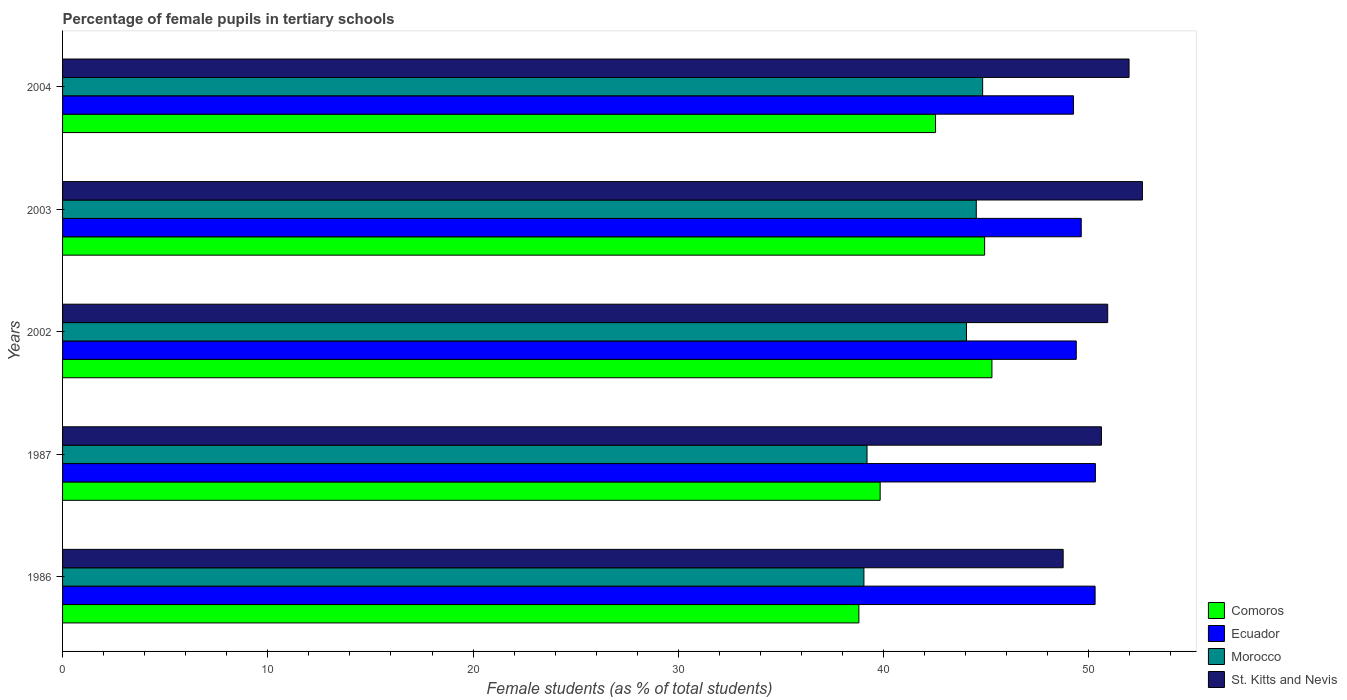How many different coloured bars are there?
Provide a succinct answer. 4. How many groups of bars are there?
Offer a very short reply. 5. Are the number of bars per tick equal to the number of legend labels?
Provide a short and direct response. Yes. How many bars are there on the 1st tick from the top?
Make the answer very short. 4. What is the label of the 2nd group of bars from the top?
Your answer should be compact. 2003. What is the percentage of female pupils in tertiary schools in St. Kitts and Nevis in 1987?
Keep it short and to the point. 50.61. Across all years, what is the maximum percentage of female pupils in tertiary schools in Morocco?
Make the answer very short. 44.83. Across all years, what is the minimum percentage of female pupils in tertiary schools in St. Kitts and Nevis?
Provide a short and direct response. 48.75. What is the total percentage of female pupils in tertiary schools in St. Kitts and Nevis in the graph?
Make the answer very short. 254.85. What is the difference between the percentage of female pupils in tertiary schools in Morocco in 2002 and that in 2004?
Make the answer very short. -0.79. What is the difference between the percentage of female pupils in tertiary schools in Morocco in 2004 and the percentage of female pupils in tertiary schools in Comoros in 2003?
Keep it short and to the point. -0.1. What is the average percentage of female pupils in tertiary schools in Comoros per year?
Offer a terse response. 42.27. In the year 1986, what is the difference between the percentage of female pupils in tertiary schools in Ecuador and percentage of female pupils in tertiary schools in Comoros?
Provide a short and direct response. 11.51. In how many years, is the percentage of female pupils in tertiary schools in St. Kitts and Nevis greater than 8 %?
Your answer should be compact. 5. What is the ratio of the percentage of female pupils in tertiary schools in Morocco in 1986 to that in 1987?
Offer a very short reply. 1. What is the difference between the highest and the second highest percentage of female pupils in tertiary schools in Ecuador?
Give a very brief answer. 0.02. What is the difference between the highest and the lowest percentage of female pupils in tertiary schools in Ecuador?
Provide a succinct answer. 1.07. In how many years, is the percentage of female pupils in tertiary schools in Morocco greater than the average percentage of female pupils in tertiary schools in Morocco taken over all years?
Give a very brief answer. 3. Is it the case that in every year, the sum of the percentage of female pupils in tertiary schools in Comoros and percentage of female pupils in tertiary schools in St. Kitts and Nevis is greater than the sum of percentage of female pupils in tertiary schools in Ecuador and percentage of female pupils in tertiary schools in Morocco?
Your response must be concise. Yes. What does the 2nd bar from the top in 2003 represents?
Keep it short and to the point. Morocco. What does the 4th bar from the bottom in 1987 represents?
Provide a succinct answer. St. Kitts and Nevis. Are all the bars in the graph horizontal?
Make the answer very short. Yes. What is the difference between two consecutive major ticks on the X-axis?
Offer a terse response. 10. Are the values on the major ticks of X-axis written in scientific E-notation?
Your answer should be very brief. No. Does the graph contain grids?
Give a very brief answer. No. Where does the legend appear in the graph?
Ensure brevity in your answer.  Bottom right. How many legend labels are there?
Your answer should be compact. 4. How are the legend labels stacked?
Ensure brevity in your answer.  Vertical. What is the title of the graph?
Provide a succinct answer. Percentage of female pupils in tertiary schools. Does "Azerbaijan" appear as one of the legend labels in the graph?
Provide a short and direct response. No. What is the label or title of the X-axis?
Your answer should be compact. Female students (as % of total students). What is the label or title of the Y-axis?
Ensure brevity in your answer.  Years. What is the Female students (as % of total students) of Comoros in 1986?
Your answer should be compact. 38.8. What is the Female students (as % of total students) of Ecuador in 1986?
Keep it short and to the point. 50.31. What is the Female students (as % of total students) in Morocco in 1986?
Give a very brief answer. 39.04. What is the Female students (as % of total students) of St. Kitts and Nevis in 1986?
Keep it short and to the point. 48.75. What is the Female students (as % of total students) of Comoros in 1987?
Make the answer very short. 39.83. What is the Female students (as % of total students) in Ecuador in 1987?
Your response must be concise. 50.32. What is the Female students (as % of total students) of Morocco in 1987?
Keep it short and to the point. 39.19. What is the Female students (as % of total students) of St. Kitts and Nevis in 1987?
Make the answer very short. 50.61. What is the Female students (as % of total students) in Comoros in 2002?
Ensure brevity in your answer.  45.28. What is the Female students (as % of total students) in Ecuador in 2002?
Make the answer very short. 49.39. What is the Female students (as % of total students) of Morocco in 2002?
Provide a short and direct response. 44.04. What is the Female students (as % of total students) in St. Kitts and Nevis in 2002?
Provide a short and direct response. 50.92. What is the Female students (as % of total students) of Comoros in 2003?
Your answer should be compact. 44.92. What is the Female students (as % of total students) in Ecuador in 2003?
Give a very brief answer. 49.63. What is the Female students (as % of total students) in Morocco in 2003?
Ensure brevity in your answer.  44.52. What is the Female students (as % of total students) of St. Kitts and Nevis in 2003?
Provide a short and direct response. 52.61. What is the Female students (as % of total students) of Comoros in 2004?
Keep it short and to the point. 42.53. What is the Female students (as % of total students) in Ecuador in 2004?
Make the answer very short. 49.25. What is the Female students (as % of total students) of Morocco in 2004?
Your response must be concise. 44.83. What is the Female students (as % of total students) in St. Kitts and Nevis in 2004?
Your answer should be very brief. 51.96. Across all years, what is the maximum Female students (as % of total students) of Comoros?
Provide a succinct answer. 45.28. Across all years, what is the maximum Female students (as % of total students) in Ecuador?
Offer a terse response. 50.32. Across all years, what is the maximum Female students (as % of total students) in Morocco?
Your answer should be very brief. 44.83. Across all years, what is the maximum Female students (as % of total students) of St. Kitts and Nevis?
Make the answer very short. 52.61. Across all years, what is the minimum Female students (as % of total students) of Comoros?
Provide a succinct answer. 38.8. Across all years, what is the minimum Female students (as % of total students) of Ecuador?
Keep it short and to the point. 49.25. Across all years, what is the minimum Female students (as % of total students) in Morocco?
Keep it short and to the point. 39.04. Across all years, what is the minimum Female students (as % of total students) in St. Kitts and Nevis?
Ensure brevity in your answer.  48.75. What is the total Female students (as % of total students) in Comoros in the graph?
Provide a succinct answer. 211.36. What is the total Female students (as % of total students) in Ecuador in the graph?
Offer a terse response. 248.9. What is the total Female students (as % of total students) of Morocco in the graph?
Provide a succinct answer. 211.62. What is the total Female students (as % of total students) in St. Kitts and Nevis in the graph?
Ensure brevity in your answer.  254.85. What is the difference between the Female students (as % of total students) of Comoros in 1986 and that in 1987?
Provide a short and direct response. -1.04. What is the difference between the Female students (as % of total students) in Ecuador in 1986 and that in 1987?
Offer a terse response. -0.02. What is the difference between the Female students (as % of total students) in Morocco in 1986 and that in 1987?
Offer a very short reply. -0.15. What is the difference between the Female students (as % of total students) of St. Kitts and Nevis in 1986 and that in 1987?
Your response must be concise. -1.86. What is the difference between the Female students (as % of total students) of Comoros in 1986 and that in 2002?
Your answer should be very brief. -6.48. What is the difference between the Female students (as % of total students) in Ecuador in 1986 and that in 2002?
Provide a succinct answer. 0.92. What is the difference between the Female students (as % of total students) in Morocco in 1986 and that in 2002?
Provide a short and direct response. -5. What is the difference between the Female students (as % of total students) in St. Kitts and Nevis in 1986 and that in 2002?
Your response must be concise. -2.17. What is the difference between the Female students (as % of total students) in Comoros in 1986 and that in 2003?
Give a very brief answer. -6.13. What is the difference between the Female students (as % of total students) of Ecuador in 1986 and that in 2003?
Give a very brief answer. 0.68. What is the difference between the Female students (as % of total students) in Morocco in 1986 and that in 2003?
Your answer should be very brief. -5.47. What is the difference between the Female students (as % of total students) of St. Kitts and Nevis in 1986 and that in 2003?
Offer a very short reply. -3.86. What is the difference between the Female students (as % of total students) in Comoros in 1986 and that in 2004?
Your answer should be very brief. -3.73. What is the difference between the Female students (as % of total students) of Ecuador in 1986 and that in 2004?
Your response must be concise. 1.05. What is the difference between the Female students (as % of total students) of Morocco in 1986 and that in 2004?
Your response must be concise. -5.78. What is the difference between the Female students (as % of total students) of St. Kitts and Nevis in 1986 and that in 2004?
Provide a short and direct response. -3.21. What is the difference between the Female students (as % of total students) of Comoros in 1987 and that in 2002?
Make the answer very short. -5.45. What is the difference between the Female students (as % of total students) of Ecuador in 1987 and that in 2002?
Provide a succinct answer. 0.93. What is the difference between the Female students (as % of total students) in Morocco in 1987 and that in 2002?
Ensure brevity in your answer.  -4.85. What is the difference between the Female students (as % of total students) of St. Kitts and Nevis in 1987 and that in 2002?
Offer a terse response. -0.31. What is the difference between the Female students (as % of total students) of Comoros in 1987 and that in 2003?
Give a very brief answer. -5.09. What is the difference between the Female students (as % of total students) of Ecuador in 1987 and that in 2003?
Offer a very short reply. 0.69. What is the difference between the Female students (as % of total students) of Morocco in 1987 and that in 2003?
Keep it short and to the point. -5.32. What is the difference between the Female students (as % of total students) of St. Kitts and Nevis in 1987 and that in 2003?
Offer a terse response. -2. What is the difference between the Female students (as % of total students) in Comoros in 1987 and that in 2004?
Your answer should be very brief. -2.7. What is the difference between the Female students (as % of total students) of Ecuador in 1987 and that in 2004?
Your response must be concise. 1.07. What is the difference between the Female students (as % of total students) in Morocco in 1987 and that in 2004?
Your answer should be very brief. -5.63. What is the difference between the Female students (as % of total students) of St. Kitts and Nevis in 1987 and that in 2004?
Your response must be concise. -1.35. What is the difference between the Female students (as % of total students) of Comoros in 2002 and that in 2003?
Provide a short and direct response. 0.36. What is the difference between the Female students (as % of total students) in Ecuador in 2002 and that in 2003?
Offer a terse response. -0.24. What is the difference between the Female students (as % of total students) of Morocco in 2002 and that in 2003?
Offer a terse response. -0.48. What is the difference between the Female students (as % of total students) in St. Kitts and Nevis in 2002 and that in 2003?
Your answer should be very brief. -1.69. What is the difference between the Female students (as % of total students) of Comoros in 2002 and that in 2004?
Give a very brief answer. 2.75. What is the difference between the Female students (as % of total students) in Ecuador in 2002 and that in 2004?
Provide a succinct answer. 0.13. What is the difference between the Female students (as % of total students) in Morocco in 2002 and that in 2004?
Give a very brief answer. -0.79. What is the difference between the Female students (as % of total students) of St. Kitts and Nevis in 2002 and that in 2004?
Your answer should be compact. -1.04. What is the difference between the Female students (as % of total students) of Comoros in 2003 and that in 2004?
Provide a short and direct response. 2.39. What is the difference between the Female students (as % of total students) in Ecuador in 2003 and that in 2004?
Ensure brevity in your answer.  0.38. What is the difference between the Female students (as % of total students) of Morocco in 2003 and that in 2004?
Give a very brief answer. -0.31. What is the difference between the Female students (as % of total students) of St. Kitts and Nevis in 2003 and that in 2004?
Your answer should be very brief. 0.65. What is the difference between the Female students (as % of total students) in Comoros in 1986 and the Female students (as % of total students) in Ecuador in 1987?
Your answer should be compact. -11.52. What is the difference between the Female students (as % of total students) of Comoros in 1986 and the Female students (as % of total students) of Morocco in 1987?
Provide a short and direct response. -0.4. What is the difference between the Female students (as % of total students) of Comoros in 1986 and the Female students (as % of total students) of St. Kitts and Nevis in 1987?
Ensure brevity in your answer.  -11.82. What is the difference between the Female students (as % of total students) of Ecuador in 1986 and the Female students (as % of total students) of Morocco in 1987?
Your response must be concise. 11.11. What is the difference between the Female students (as % of total students) in Ecuador in 1986 and the Female students (as % of total students) in St. Kitts and Nevis in 1987?
Ensure brevity in your answer.  -0.31. What is the difference between the Female students (as % of total students) of Morocco in 1986 and the Female students (as % of total students) of St. Kitts and Nevis in 1987?
Offer a very short reply. -11.57. What is the difference between the Female students (as % of total students) in Comoros in 1986 and the Female students (as % of total students) in Ecuador in 2002?
Keep it short and to the point. -10.59. What is the difference between the Female students (as % of total students) of Comoros in 1986 and the Female students (as % of total students) of Morocco in 2002?
Provide a short and direct response. -5.24. What is the difference between the Female students (as % of total students) of Comoros in 1986 and the Female students (as % of total students) of St. Kitts and Nevis in 2002?
Keep it short and to the point. -12.12. What is the difference between the Female students (as % of total students) in Ecuador in 1986 and the Female students (as % of total students) in Morocco in 2002?
Give a very brief answer. 6.26. What is the difference between the Female students (as % of total students) in Ecuador in 1986 and the Female students (as % of total students) in St. Kitts and Nevis in 2002?
Ensure brevity in your answer.  -0.61. What is the difference between the Female students (as % of total students) in Morocco in 1986 and the Female students (as % of total students) in St. Kitts and Nevis in 2002?
Offer a very short reply. -11.88. What is the difference between the Female students (as % of total students) in Comoros in 1986 and the Female students (as % of total students) in Ecuador in 2003?
Offer a very short reply. -10.83. What is the difference between the Female students (as % of total students) in Comoros in 1986 and the Female students (as % of total students) in Morocco in 2003?
Offer a terse response. -5.72. What is the difference between the Female students (as % of total students) in Comoros in 1986 and the Female students (as % of total students) in St. Kitts and Nevis in 2003?
Keep it short and to the point. -13.81. What is the difference between the Female students (as % of total students) in Ecuador in 1986 and the Female students (as % of total students) in Morocco in 2003?
Offer a terse response. 5.79. What is the difference between the Female students (as % of total students) in Ecuador in 1986 and the Female students (as % of total students) in St. Kitts and Nevis in 2003?
Keep it short and to the point. -2.31. What is the difference between the Female students (as % of total students) in Morocco in 1986 and the Female students (as % of total students) in St. Kitts and Nevis in 2003?
Your answer should be compact. -13.57. What is the difference between the Female students (as % of total students) of Comoros in 1986 and the Female students (as % of total students) of Ecuador in 2004?
Your answer should be compact. -10.46. What is the difference between the Female students (as % of total students) in Comoros in 1986 and the Female students (as % of total students) in Morocco in 2004?
Make the answer very short. -6.03. What is the difference between the Female students (as % of total students) of Comoros in 1986 and the Female students (as % of total students) of St. Kitts and Nevis in 2004?
Keep it short and to the point. -13.16. What is the difference between the Female students (as % of total students) in Ecuador in 1986 and the Female students (as % of total students) in Morocco in 2004?
Make the answer very short. 5.48. What is the difference between the Female students (as % of total students) of Ecuador in 1986 and the Female students (as % of total students) of St. Kitts and Nevis in 2004?
Provide a short and direct response. -1.65. What is the difference between the Female students (as % of total students) in Morocco in 1986 and the Female students (as % of total students) in St. Kitts and Nevis in 2004?
Give a very brief answer. -12.92. What is the difference between the Female students (as % of total students) of Comoros in 1987 and the Female students (as % of total students) of Ecuador in 2002?
Offer a terse response. -9.55. What is the difference between the Female students (as % of total students) in Comoros in 1987 and the Female students (as % of total students) in Morocco in 2002?
Keep it short and to the point. -4.21. What is the difference between the Female students (as % of total students) in Comoros in 1987 and the Female students (as % of total students) in St. Kitts and Nevis in 2002?
Make the answer very short. -11.09. What is the difference between the Female students (as % of total students) in Ecuador in 1987 and the Female students (as % of total students) in Morocco in 2002?
Your response must be concise. 6.28. What is the difference between the Female students (as % of total students) of Ecuador in 1987 and the Female students (as % of total students) of St. Kitts and Nevis in 2002?
Offer a very short reply. -0.6. What is the difference between the Female students (as % of total students) of Morocco in 1987 and the Female students (as % of total students) of St. Kitts and Nevis in 2002?
Offer a terse response. -11.73. What is the difference between the Female students (as % of total students) of Comoros in 1987 and the Female students (as % of total students) of Ecuador in 2003?
Offer a very short reply. -9.8. What is the difference between the Female students (as % of total students) of Comoros in 1987 and the Female students (as % of total students) of Morocco in 2003?
Make the answer very short. -4.68. What is the difference between the Female students (as % of total students) of Comoros in 1987 and the Female students (as % of total students) of St. Kitts and Nevis in 2003?
Make the answer very short. -12.78. What is the difference between the Female students (as % of total students) in Ecuador in 1987 and the Female students (as % of total students) in Morocco in 2003?
Keep it short and to the point. 5.8. What is the difference between the Female students (as % of total students) of Ecuador in 1987 and the Female students (as % of total students) of St. Kitts and Nevis in 2003?
Provide a short and direct response. -2.29. What is the difference between the Female students (as % of total students) in Morocco in 1987 and the Female students (as % of total students) in St. Kitts and Nevis in 2003?
Provide a succinct answer. -13.42. What is the difference between the Female students (as % of total students) of Comoros in 1987 and the Female students (as % of total students) of Ecuador in 2004?
Offer a terse response. -9.42. What is the difference between the Female students (as % of total students) in Comoros in 1987 and the Female students (as % of total students) in Morocco in 2004?
Give a very brief answer. -4.99. What is the difference between the Female students (as % of total students) in Comoros in 1987 and the Female students (as % of total students) in St. Kitts and Nevis in 2004?
Give a very brief answer. -12.13. What is the difference between the Female students (as % of total students) of Ecuador in 1987 and the Female students (as % of total students) of Morocco in 2004?
Make the answer very short. 5.49. What is the difference between the Female students (as % of total students) of Ecuador in 1987 and the Female students (as % of total students) of St. Kitts and Nevis in 2004?
Keep it short and to the point. -1.64. What is the difference between the Female students (as % of total students) in Morocco in 1987 and the Female students (as % of total students) in St. Kitts and Nevis in 2004?
Offer a terse response. -12.77. What is the difference between the Female students (as % of total students) of Comoros in 2002 and the Female students (as % of total students) of Ecuador in 2003?
Keep it short and to the point. -4.35. What is the difference between the Female students (as % of total students) in Comoros in 2002 and the Female students (as % of total students) in Morocco in 2003?
Offer a terse response. 0.76. What is the difference between the Female students (as % of total students) in Comoros in 2002 and the Female students (as % of total students) in St. Kitts and Nevis in 2003?
Give a very brief answer. -7.33. What is the difference between the Female students (as % of total students) in Ecuador in 2002 and the Female students (as % of total students) in Morocco in 2003?
Offer a terse response. 4.87. What is the difference between the Female students (as % of total students) in Ecuador in 2002 and the Female students (as % of total students) in St. Kitts and Nevis in 2003?
Your answer should be compact. -3.22. What is the difference between the Female students (as % of total students) of Morocco in 2002 and the Female students (as % of total students) of St. Kitts and Nevis in 2003?
Your answer should be compact. -8.57. What is the difference between the Female students (as % of total students) in Comoros in 2002 and the Female students (as % of total students) in Ecuador in 2004?
Make the answer very short. -3.97. What is the difference between the Female students (as % of total students) in Comoros in 2002 and the Female students (as % of total students) in Morocco in 2004?
Offer a very short reply. 0.45. What is the difference between the Female students (as % of total students) of Comoros in 2002 and the Female students (as % of total students) of St. Kitts and Nevis in 2004?
Provide a succinct answer. -6.68. What is the difference between the Female students (as % of total students) of Ecuador in 2002 and the Female students (as % of total students) of Morocco in 2004?
Offer a very short reply. 4.56. What is the difference between the Female students (as % of total students) in Ecuador in 2002 and the Female students (as % of total students) in St. Kitts and Nevis in 2004?
Provide a short and direct response. -2.57. What is the difference between the Female students (as % of total students) of Morocco in 2002 and the Female students (as % of total students) of St. Kitts and Nevis in 2004?
Give a very brief answer. -7.92. What is the difference between the Female students (as % of total students) of Comoros in 2003 and the Female students (as % of total students) of Ecuador in 2004?
Provide a succinct answer. -4.33. What is the difference between the Female students (as % of total students) of Comoros in 2003 and the Female students (as % of total students) of Morocco in 2004?
Provide a short and direct response. 0.1. What is the difference between the Female students (as % of total students) of Comoros in 2003 and the Female students (as % of total students) of St. Kitts and Nevis in 2004?
Make the answer very short. -7.04. What is the difference between the Female students (as % of total students) of Ecuador in 2003 and the Female students (as % of total students) of Morocco in 2004?
Your answer should be compact. 4.8. What is the difference between the Female students (as % of total students) in Ecuador in 2003 and the Female students (as % of total students) in St. Kitts and Nevis in 2004?
Your response must be concise. -2.33. What is the difference between the Female students (as % of total students) in Morocco in 2003 and the Female students (as % of total students) in St. Kitts and Nevis in 2004?
Your response must be concise. -7.44. What is the average Female students (as % of total students) of Comoros per year?
Offer a terse response. 42.27. What is the average Female students (as % of total students) of Ecuador per year?
Give a very brief answer. 49.78. What is the average Female students (as % of total students) in Morocco per year?
Offer a terse response. 42.32. What is the average Female students (as % of total students) of St. Kitts and Nevis per year?
Ensure brevity in your answer.  50.97. In the year 1986, what is the difference between the Female students (as % of total students) in Comoros and Female students (as % of total students) in Ecuador?
Ensure brevity in your answer.  -11.51. In the year 1986, what is the difference between the Female students (as % of total students) of Comoros and Female students (as % of total students) of Morocco?
Offer a very short reply. -0.25. In the year 1986, what is the difference between the Female students (as % of total students) of Comoros and Female students (as % of total students) of St. Kitts and Nevis?
Ensure brevity in your answer.  -9.95. In the year 1986, what is the difference between the Female students (as % of total students) of Ecuador and Female students (as % of total students) of Morocco?
Provide a short and direct response. 11.26. In the year 1986, what is the difference between the Female students (as % of total students) of Ecuador and Female students (as % of total students) of St. Kitts and Nevis?
Your answer should be compact. 1.56. In the year 1986, what is the difference between the Female students (as % of total students) of Morocco and Female students (as % of total students) of St. Kitts and Nevis?
Provide a short and direct response. -9.71. In the year 1987, what is the difference between the Female students (as % of total students) of Comoros and Female students (as % of total students) of Ecuador?
Ensure brevity in your answer.  -10.49. In the year 1987, what is the difference between the Female students (as % of total students) of Comoros and Female students (as % of total students) of Morocco?
Give a very brief answer. 0.64. In the year 1987, what is the difference between the Female students (as % of total students) of Comoros and Female students (as % of total students) of St. Kitts and Nevis?
Provide a succinct answer. -10.78. In the year 1987, what is the difference between the Female students (as % of total students) of Ecuador and Female students (as % of total students) of Morocco?
Your response must be concise. 11.13. In the year 1987, what is the difference between the Female students (as % of total students) of Ecuador and Female students (as % of total students) of St. Kitts and Nevis?
Your response must be concise. -0.29. In the year 1987, what is the difference between the Female students (as % of total students) in Morocco and Female students (as % of total students) in St. Kitts and Nevis?
Provide a short and direct response. -11.42. In the year 2002, what is the difference between the Female students (as % of total students) in Comoros and Female students (as % of total students) in Ecuador?
Provide a succinct answer. -4.11. In the year 2002, what is the difference between the Female students (as % of total students) of Comoros and Female students (as % of total students) of Morocco?
Ensure brevity in your answer.  1.24. In the year 2002, what is the difference between the Female students (as % of total students) in Comoros and Female students (as % of total students) in St. Kitts and Nevis?
Keep it short and to the point. -5.64. In the year 2002, what is the difference between the Female students (as % of total students) in Ecuador and Female students (as % of total students) in Morocco?
Provide a short and direct response. 5.35. In the year 2002, what is the difference between the Female students (as % of total students) in Ecuador and Female students (as % of total students) in St. Kitts and Nevis?
Offer a very short reply. -1.53. In the year 2002, what is the difference between the Female students (as % of total students) of Morocco and Female students (as % of total students) of St. Kitts and Nevis?
Give a very brief answer. -6.88. In the year 2003, what is the difference between the Female students (as % of total students) in Comoros and Female students (as % of total students) in Ecuador?
Make the answer very short. -4.71. In the year 2003, what is the difference between the Female students (as % of total students) of Comoros and Female students (as % of total students) of Morocco?
Offer a terse response. 0.41. In the year 2003, what is the difference between the Female students (as % of total students) of Comoros and Female students (as % of total students) of St. Kitts and Nevis?
Provide a succinct answer. -7.69. In the year 2003, what is the difference between the Female students (as % of total students) in Ecuador and Female students (as % of total students) in Morocco?
Provide a succinct answer. 5.11. In the year 2003, what is the difference between the Female students (as % of total students) in Ecuador and Female students (as % of total students) in St. Kitts and Nevis?
Your response must be concise. -2.98. In the year 2003, what is the difference between the Female students (as % of total students) in Morocco and Female students (as % of total students) in St. Kitts and Nevis?
Your response must be concise. -8.09. In the year 2004, what is the difference between the Female students (as % of total students) of Comoros and Female students (as % of total students) of Ecuador?
Ensure brevity in your answer.  -6.72. In the year 2004, what is the difference between the Female students (as % of total students) of Comoros and Female students (as % of total students) of Morocco?
Make the answer very short. -2.3. In the year 2004, what is the difference between the Female students (as % of total students) in Comoros and Female students (as % of total students) in St. Kitts and Nevis?
Offer a very short reply. -9.43. In the year 2004, what is the difference between the Female students (as % of total students) in Ecuador and Female students (as % of total students) in Morocco?
Your response must be concise. 4.43. In the year 2004, what is the difference between the Female students (as % of total students) in Ecuador and Female students (as % of total students) in St. Kitts and Nevis?
Ensure brevity in your answer.  -2.71. In the year 2004, what is the difference between the Female students (as % of total students) of Morocco and Female students (as % of total students) of St. Kitts and Nevis?
Provide a succinct answer. -7.13. What is the ratio of the Female students (as % of total students) of Ecuador in 1986 to that in 1987?
Provide a succinct answer. 1. What is the ratio of the Female students (as % of total students) of Morocco in 1986 to that in 1987?
Your response must be concise. 1. What is the ratio of the Female students (as % of total students) in St. Kitts and Nevis in 1986 to that in 1987?
Keep it short and to the point. 0.96. What is the ratio of the Female students (as % of total students) of Comoros in 1986 to that in 2002?
Make the answer very short. 0.86. What is the ratio of the Female students (as % of total students) of Ecuador in 1986 to that in 2002?
Offer a very short reply. 1.02. What is the ratio of the Female students (as % of total students) in Morocco in 1986 to that in 2002?
Your answer should be compact. 0.89. What is the ratio of the Female students (as % of total students) of St. Kitts and Nevis in 1986 to that in 2002?
Make the answer very short. 0.96. What is the ratio of the Female students (as % of total students) in Comoros in 1986 to that in 2003?
Make the answer very short. 0.86. What is the ratio of the Female students (as % of total students) of Ecuador in 1986 to that in 2003?
Your response must be concise. 1.01. What is the ratio of the Female students (as % of total students) in Morocco in 1986 to that in 2003?
Keep it short and to the point. 0.88. What is the ratio of the Female students (as % of total students) in St. Kitts and Nevis in 1986 to that in 2003?
Provide a short and direct response. 0.93. What is the ratio of the Female students (as % of total students) in Comoros in 1986 to that in 2004?
Your response must be concise. 0.91. What is the ratio of the Female students (as % of total students) of Ecuador in 1986 to that in 2004?
Provide a short and direct response. 1.02. What is the ratio of the Female students (as % of total students) in Morocco in 1986 to that in 2004?
Your response must be concise. 0.87. What is the ratio of the Female students (as % of total students) in St. Kitts and Nevis in 1986 to that in 2004?
Provide a short and direct response. 0.94. What is the ratio of the Female students (as % of total students) in Comoros in 1987 to that in 2002?
Provide a succinct answer. 0.88. What is the ratio of the Female students (as % of total students) in Ecuador in 1987 to that in 2002?
Your answer should be very brief. 1.02. What is the ratio of the Female students (as % of total students) of Morocco in 1987 to that in 2002?
Make the answer very short. 0.89. What is the ratio of the Female students (as % of total students) in St. Kitts and Nevis in 1987 to that in 2002?
Offer a very short reply. 0.99. What is the ratio of the Female students (as % of total students) in Comoros in 1987 to that in 2003?
Ensure brevity in your answer.  0.89. What is the ratio of the Female students (as % of total students) of Ecuador in 1987 to that in 2003?
Offer a terse response. 1.01. What is the ratio of the Female students (as % of total students) of Morocco in 1987 to that in 2003?
Provide a short and direct response. 0.88. What is the ratio of the Female students (as % of total students) in St. Kitts and Nevis in 1987 to that in 2003?
Provide a succinct answer. 0.96. What is the ratio of the Female students (as % of total students) in Comoros in 1987 to that in 2004?
Make the answer very short. 0.94. What is the ratio of the Female students (as % of total students) in Ecuador in 1987 to that in 2004?
Ensure brevity in your answer.  1.02. What is the ratio of the Female students (as % of total students) in Morocco in 1987 to that in 2004?
Provide a short and direct response. 0.87. What is the ratio of the Female students (as % of total students) of St. Kitts and Nevis in 1987 to that in 2004?
Give a very brief answer. 0.97. What is the ratio of the Female students (as % of total students) of Comoros in 2002 to that in 2003?
Offer a terse response. 1.01. What is the ratio of the Female students (as % of total students) in Ecuador in 2002 to that in 2003?
Keep it short and to the point. 1. What is the ratio of the Female students (as % of total students) in Morocco in 2002 to that in 2003?
Offer a terse response. 0.99. What is the ratio of the Female students (as % of total students) in St. Kitts and Nevis in 2002 to that in 2003?
Provide a succinct answer. 0.97. What is the ratio of the Female students (as % of total students) in Comoros in 2002 to that in 2004?
Your answer should be compact. 1.06. What is the ratio of the Female students (as % of total students) in Morocco in 2002 to that in 2004?
Offer a very short reply. 0.98. What is the ratio of the Female students (as % of total students) of St. Kitts and Nevis in 2002 to that in 2004?
Make the answer very short. 0.98. What is the ratio of the Female students (as % of total students) in Comoros in 2003 to that in 2004?
Provide a succinct answer. 1.06. What is the ratio of the Female students (as % of total students) in Ecuador in 2003 to that in 2004?
Your answer should be very brief. 1.01. What is the ratio of the Female students (as % of total students) of St. Kitts and Nevis in 2003 to that in 2004?
Provide a succinct answer. 1.01. What is the difference between the highest and the second highest Female students (as % of total students) in Comoros?
Offer a very short reply. 0.36. What is the difference between the highest and the second highest Female students (as % of total students) of Ecuador?
Your answer should be very brief. 0.02. What is the difference between the highest and the second highest Female students (as % of total students) in Morocco?
Give a very brief answer. 0.31. What is the difference between the highest and the second highest Female students (as % of total students) of St. Kitts and Nevis?
Keep it short and to the point. 0.65. What is the difference between the highest and the lowest Female students (as % of total students) of Comoros?
Ensure brevity in your answer.  6.48. What is the difference between the highest and the lowest Female students (as % of total students) in Ecuador?
Your answer should be very brief. 1.07. What is the difference between the highest and the lowest Female students (as % of total students) of Morocco?
Your answer should be compact. 5.78. What is the difference between the highest and the lowest Female students (as % of total students) of St. Kitts and Nevis?
Your answer should be compact. 3.86. 